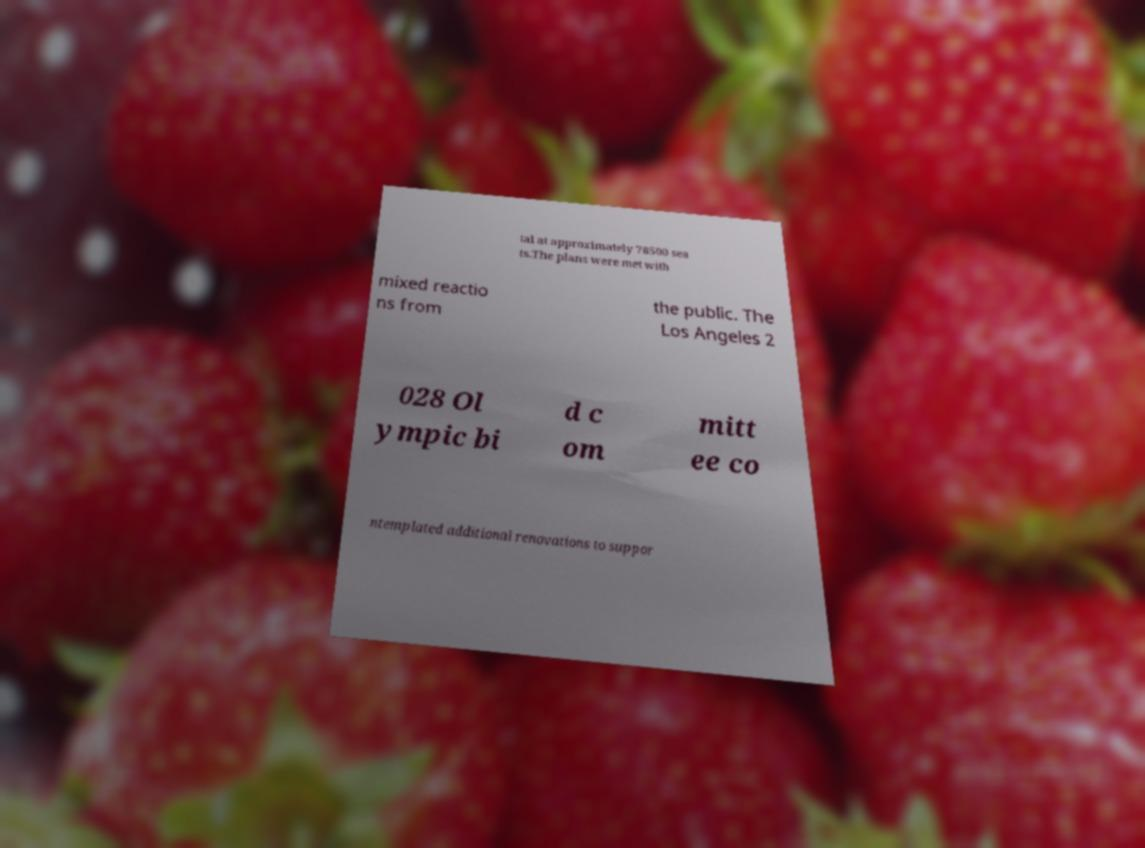I need the written content from this picture converted into text. Can you do that? tal at approximately 78500 sea ts.The plans were met with mixed reactio ns from the public. The Los Angeles 2 028 Ol ympic bi d c om mitt ee co ntemplated additional renovations to suppor 